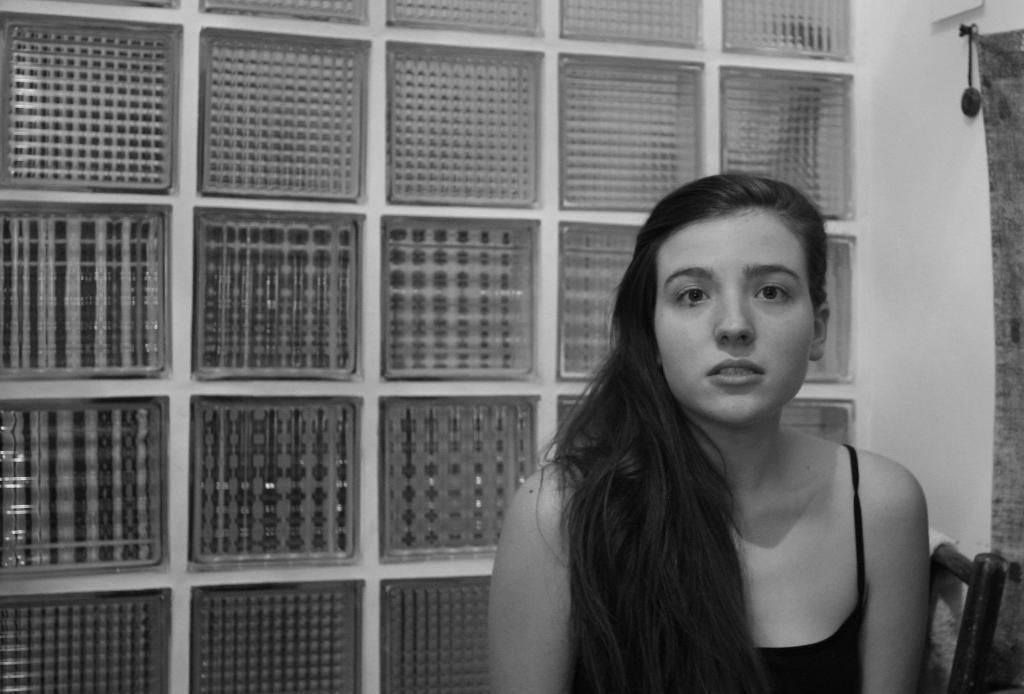What is the color scheme of the image? The image is black and white. What is the person in the image doing? The person is sitting on a chair in the image. What can be seen in the background of the image? There is a wall in the background of the image. Are there any objects on the wall in the background? Yes, there are objects on the wall in the background. What type of vacation is the person planning based on the image? There is no indication of a vacation in the image; it only shows a person sitting on a chair with a wall in the background. Can you tell me how many tubs are visible in the image? There are no tubs present in the image. 